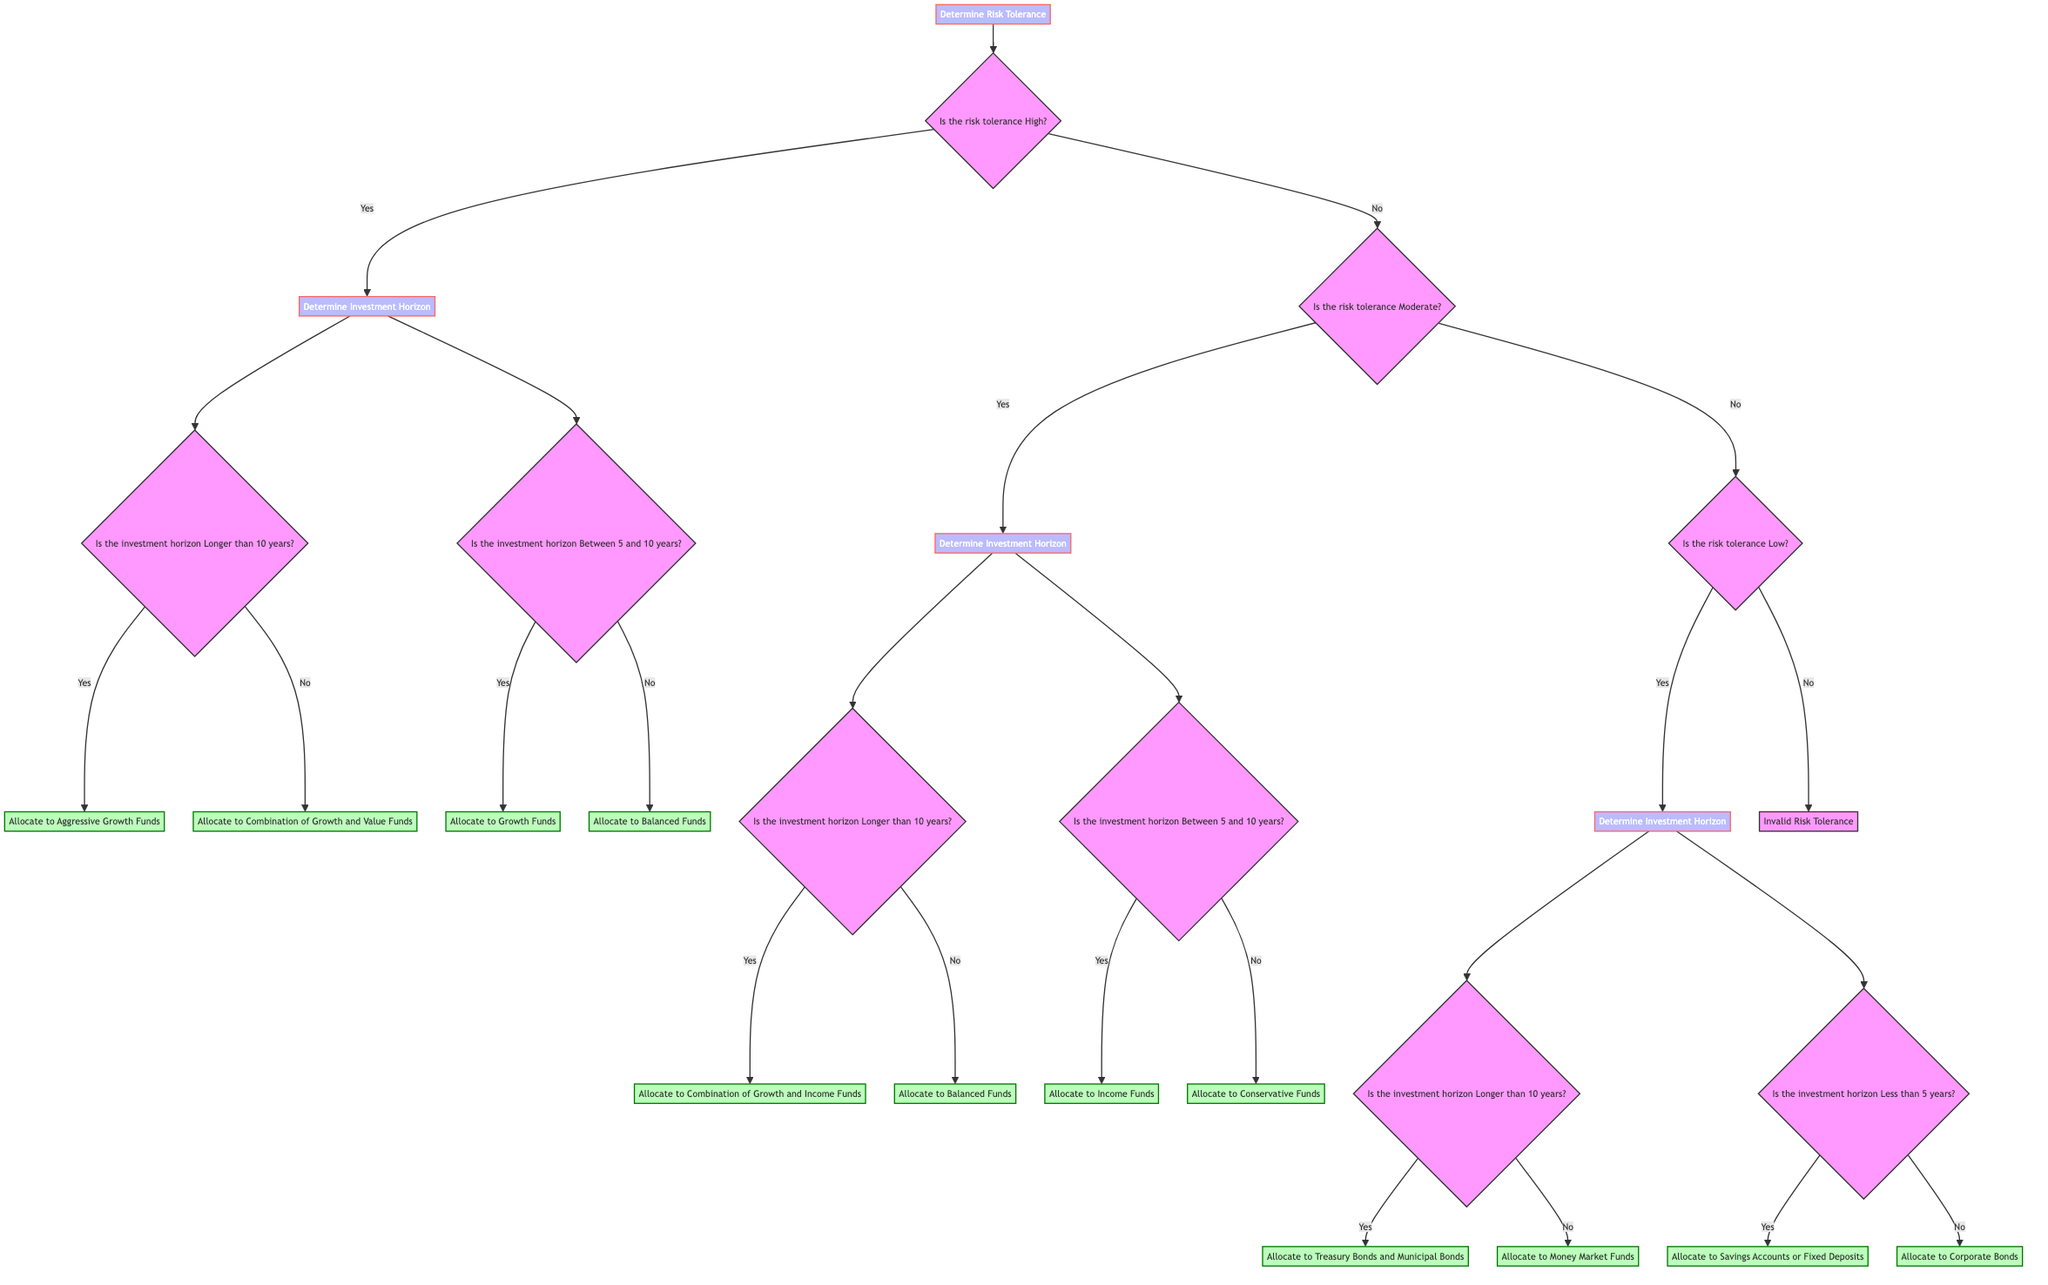What is the first decision in the tree? The first decision in the tree is "Determine Risk Tolerance." This is the starting point of the decision-making process regarding investment portfolio allocation.
Answer: Determine Risk Tolerance How many main risk tolerance categories are represented in the tree? The tree represents three main risk tolerance categories: High, Moderate, and Low. Each category leads to different investment strategies based on further decisions regarding investment horizon.
Answer: Three If a person has a high risk tolerance and their investment horizon is longer than 10 years, what is the allocation? Following the path in the tree, if the risk tolerance is high and the investment horizon is longer than 10 years, the allocation is to "Aggressive Growth Funds." This is derived from the yes path of both relevant questions.
Answer: Allocate to Aggressive Growth Funds What allocation is suggested for someone with a low risk tolerance and an investment horizon less than 5 years? According to the decision tree, a person with low risk tolerance and an investment horizon less than 5 years should allocate to "Savings Accounts or Fixed Deposits." This result comes from the decisions leading to that specific outcome in the tree.
Answer: Allocate to Savings Accounts or Fixed Deposits What is the relationship between moderate risk tolerance and balanced funds? The relationship is that individuals with moderate risk tolerance can allocate to "Balanced Funds" if their investment horizon is less than 10 years, or to "Combination of Growth and Income Funds" if their horizon is longer than 10 years. Both allocations depend on the additional question of investment horizon.
Answer: Allocation depends on investment horizon What happens if the risk tolerance is not classified as high, moderate, or low? If the risk tolerance is not classified as high, moderate, or low, the tree indicates "Invalid Risk Tolerance." This serves as a filter ensuring appropriate categorization before moving to investment strategy decisions.
Answer: Invalid Risk Tolerance If a person has a moderate risk tolerance and their investment horizon is between 5 and 10 years, what should they allocate to? The appropriate allocation for someone with a moderate risk tolerance and an investment horizon between 5 and 10 years is "Income Funds," as indicated by the relevant path in the decision tree.
Answer: Allocate to Income Funds How many total nodes appear in the decision tree? The total number of nodes in the decision tree is 12. This includes all decision points and allocation outcomes outlined in the structure of the tree.
Answer: Twelve 